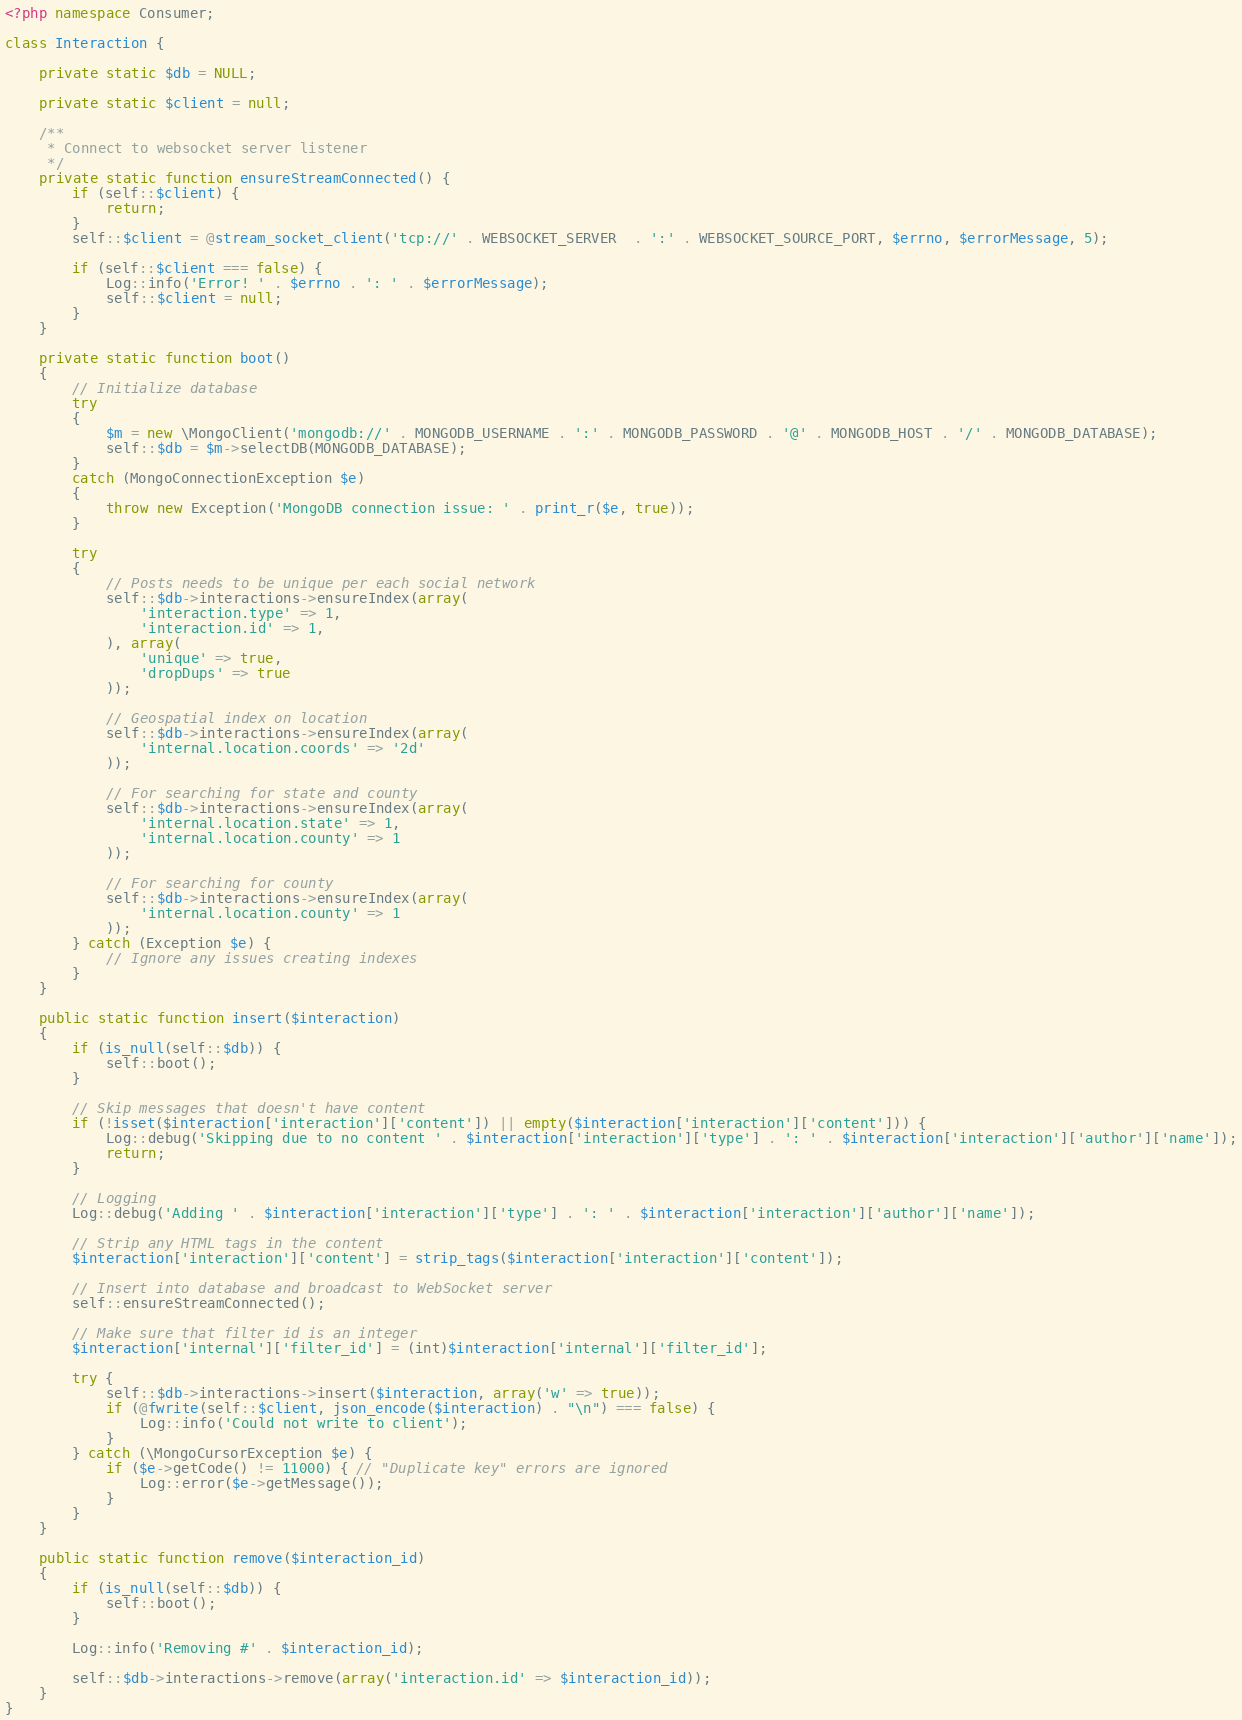<code> <loc_0><loc_0><loc_500><loc_500><_PHP_><?php namespace Consumer;

class Interaction {
	
	private static $db = NULL;

	private static $client = null;

    /**
     * Connect to websocket server listener
     */
    private static function ensureStreamConnected() {
        if (self::$client) {
            return;
        }
        self::$client = @stream_socket_client('tcp://' . WEBSOCKET_SERVER  . ':' . WEBSOCKET_SOURCE_PORT, $errno, $errorMessage, 5);

        if (self::$client === false) {
        	Log::info('Error! ' . $errno . ': ' . $errorMessage);
            self::$client = null;
        }
    }

	private static function boot()
	{
		// Initialize database
		try
		{
		    $m = new \MongoClient('mongodb://' . MONGODB_USERNAME . ':' . MONGODB_PASSWORD . '@' . MONGODB_HOST . '/' . MONGODB_DATABASE);
		    self::$db = $m->selectDB(MONGODB_DATABASE);
		}
		catch (MongoConnectionException $e)
		{
		    throw new Exception('MongoDB connection issue: ' . print_r($e, true));
		}
		
		try
		{
			// Posts needs to be unique per each social network
	        self::$db->interactions->ensureIndex(array(
	            'interaction.type' => 1,
	            'interaction.id' => 1,
	        ), array(
	            'unique' => true,
	            'dropDups' => true
	        ));

	        // Geospatial index on location
	        self::$db->interactions->ensureIndex(array(
	            'internal.location.coords' => '2d'
	        ));

	        // For searching for state and county
	        self::$db->interactions->ensureIndex(array(
	            'internal.location.state' => 1,
	            'internal.location.county' => 1
	        ));

	        // For searching for county
	        self::$db->interactions->ensureIndex(array(
	            'internal.location.county' => 1
	        ));
	    } catch (Exception $e) {
	    	// Ignore any issues creating indexes
	    }
	}

	public static function insert($interaction)
	{
		if (is_null(self::$db)) {
			self::boot();
		}
		
		// Skip messages that doesn't have content
		if (!isset($interaction['interaction']['content']) || empty($interaction['interaction']['content'])) {
			Log::debug('Skipping due to no content ' . $interaction['interaction']['type'] . ': ' . $interaction['interaction']['author']['name']);
			return;
		}

		// Logging
		Log::debug('Adding ' . $interaction['interaction']['type'] . ': ' . $interaction['interaction']['author']['name']);

		// Strip any HTML tags in the content
		$interaction['interaction']['content'] = strip_tags($interaction['interaction']['content']);

		// Insert into database and broadcast to WebSocket server
		self::ensureStreamConnected();

		// Make sure that filter id is an integer
		$interaction['internal']['filter_id'] = (int)$interaction['internal']['filter_id'];

		try {
			self::$db->interactions->insert($interaction, array('w' => true));
			if (@fwrite(self::$client, json_encode($interaction) . "\n") === false) {
				Log::info('Could not write to client');
			}
		} catch (\MongoCursorException $e) {
			if ($e->getCode() != 11000) { // "Duplicate key" errors are ignored
				Log::error($e->getMessage());
			}
		}
	}

	public static function remove($interaction_id)
	{
		if (is_null(self::$db)) {
			self::boot();
		}

		Log::info('Removing #' . $interaction_id);

        self::$db->interactions->remove(array('interaction.id' => $interaction_id));
	}
}</code> 